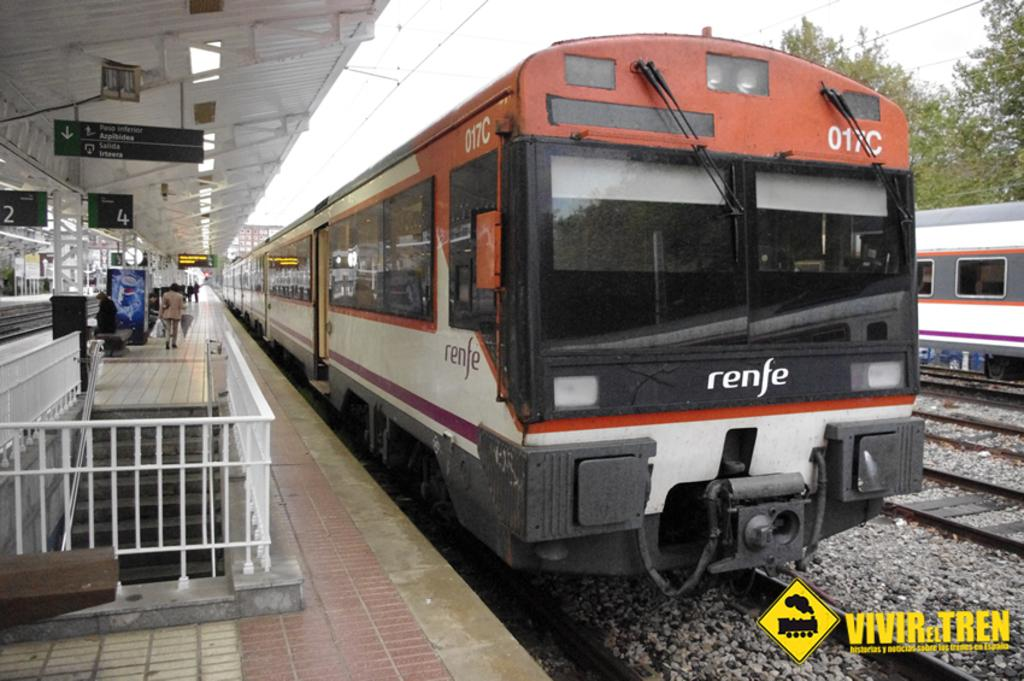<image>
Write a terse but informative summary of the picture. A renfe train sitting at one of the stops 